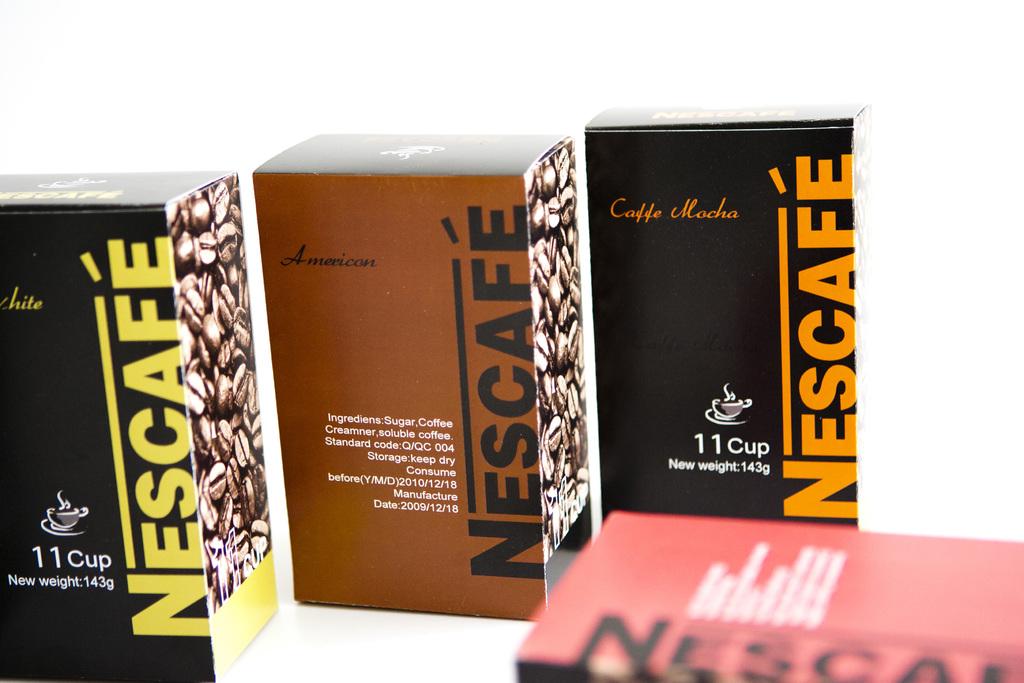What type of coffee is in the right of the three boxes?
Give a very brief answer. Nescafe. The brand is nescafe?
Provide a short and direct response. Yes. 